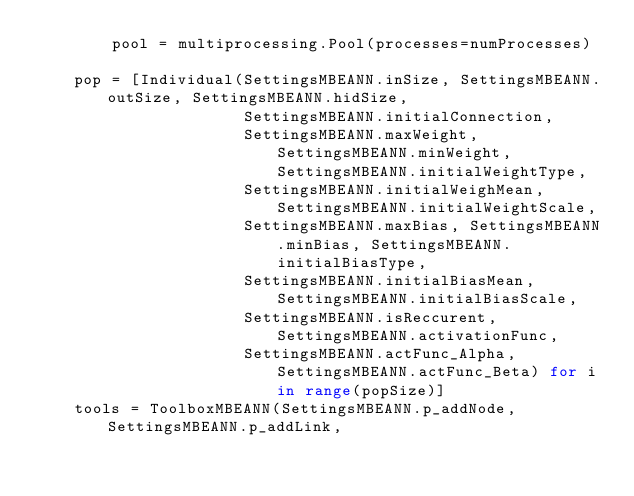<code> <loc_0><loc_0><loc_500><loc_500><_Python_>        pool = multiprocessing.Pool(processes=numProcesses)

    pop = [Individual(SettingsMBEANN.inSize, SettingsMBEANN.outSize, SettingsMBEANN.hidSize,
                      SettingsMBEANN.initialConnection,
                      SettingsMBEANN.maxWeight, SettingsMBEANN.minWeight, SettingsMBEANN.initialWeightType,
                      SettingsMBEANN.initialWeighMean, SettingsMBEANN.initialWeightScale,
                      SettingsMBEANN.maxBias, SettingsMBEANN.minBias, SettingsMBEANN.initialBiasType,
                      SettingsMBEANN.initialBiasMean, SettingsMBEANN.initialBiasScale,
                      SettingsMBEANN.isReccurent, SettingsMBEANN.activationFunc,
                      SettingsMBEANN.actFunc_Alpha, SettingsMBEANN.actFunc_Beta) for i in range(popSize)]
    tools = ToolboxMBEANN(SettingsMBEANN.p_addNode, SettingsMBEANN.p_addLink,</code> 